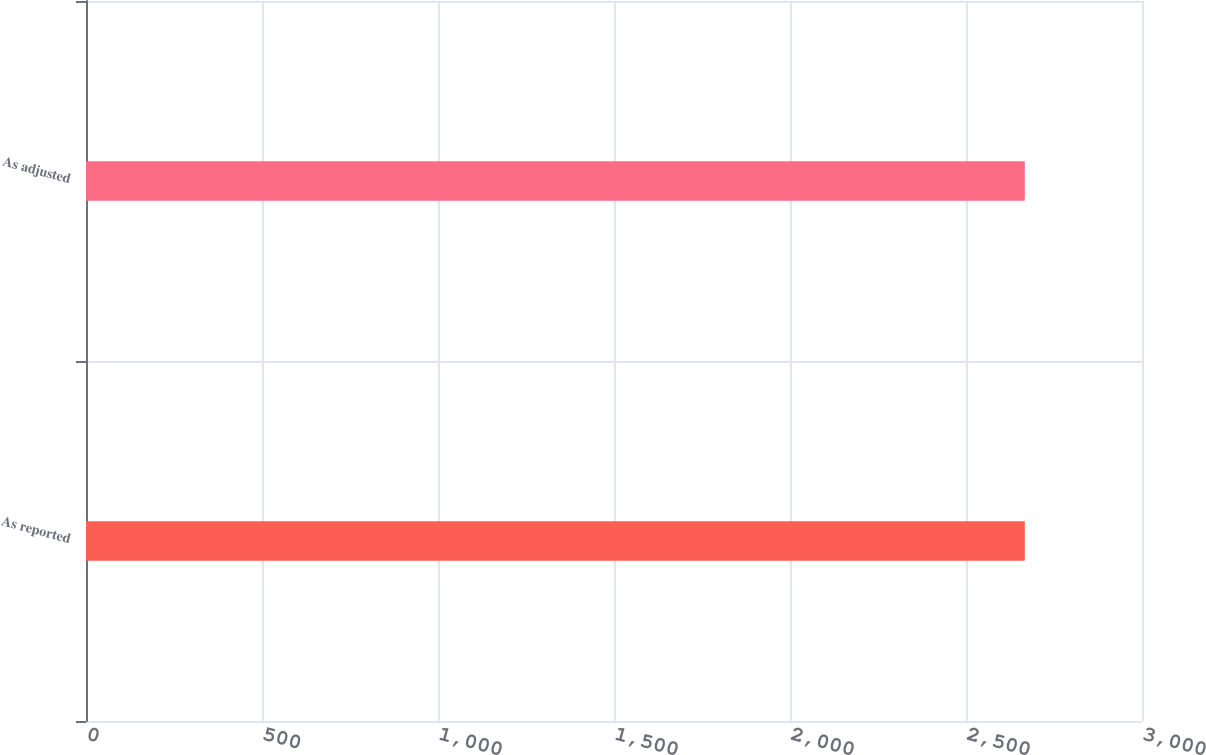<chart> <loc_0><loc_0><loc_500><loc_500><bar_chart><fcel>As reported<fcel>As adjusted<nl><fcel>2667<fcel>2667.1<nl></chart> 